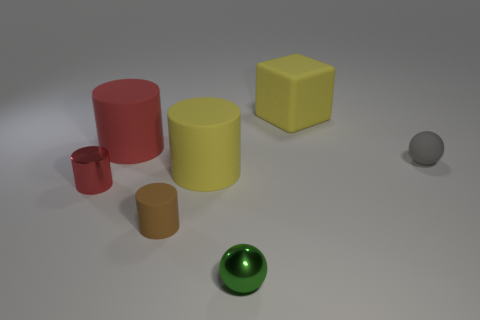Subtract 1 cylinders. How many cylinders are left? 3 Subtract all cyan cubes. Subtract all red balls. How many cubes are left? 1 Add 1 small rubber balls. How many objects exist? 8 Subtract all spheres. How many objects are left? 5 Subtract all small green metal objects. Subtract all small rubber cylinders. How many objects are left? 5 Add 4 green metal spheres. How many green metal spheres are left? 5 Add 1 big red rubber cylinders. How many big red rubber cylinders exist? 2 Subtract 0 purple cylinders. How many objects are left? 7 